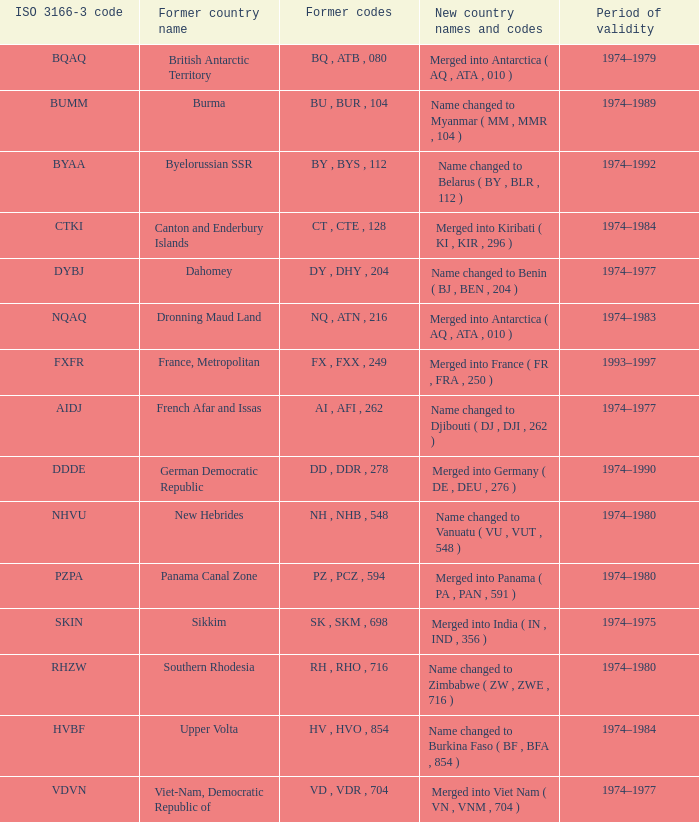Name the former codes for  merged into panama ( pa , pan , 591 ) PZ , PCZ , 594. 